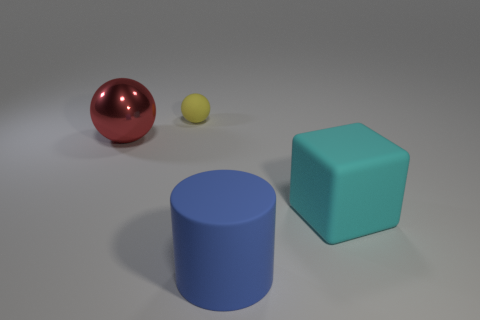Add 3 yellow objects. How many objects exist? 7 Subtract all blocks. How many objects are left? 3 Add 4 blocks. How many blocks are left? 5 Add 1 big cyan cubes. How many big cyan cubes exist? 2 Subtract 1 red spheres. How many objects are left? 3 Subtract all red shiny balls. Subtract all large shiny balls. How many objects are left? 2 